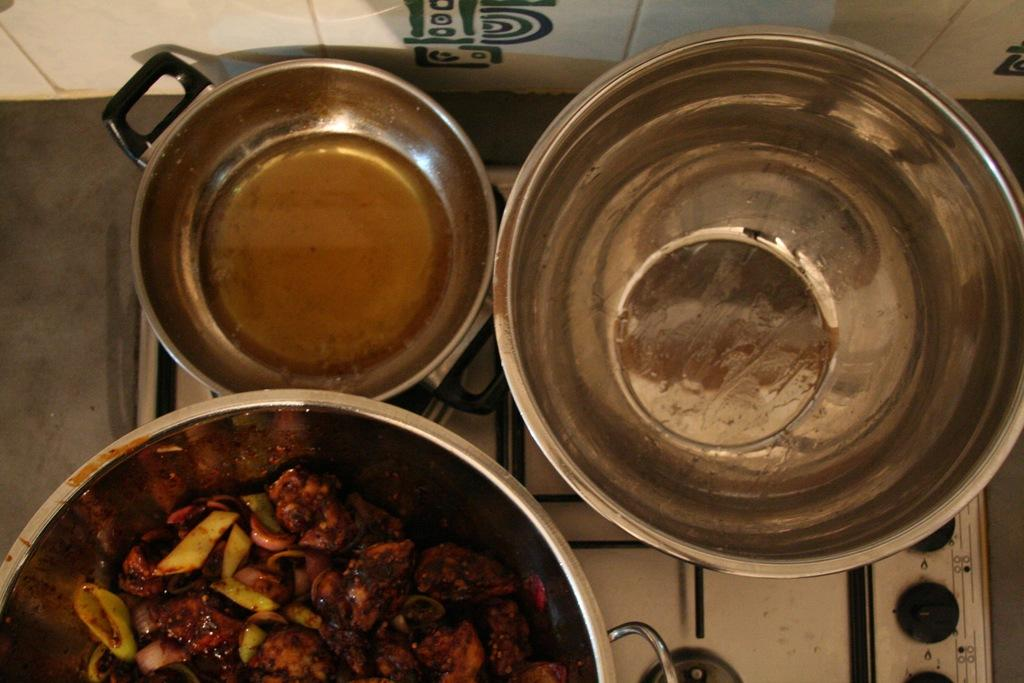How many bowls are visible in the image? There are three bowls in the image. What is in the bowls? The bowls contain food and oil. Where are the bowls located? The bowls are on a stove. What is visible behind the stove? There is a wall behind the stove. How many toothbrushes are placed on the chairs in the image? There are no toothbrushes or chairs present in the image. 